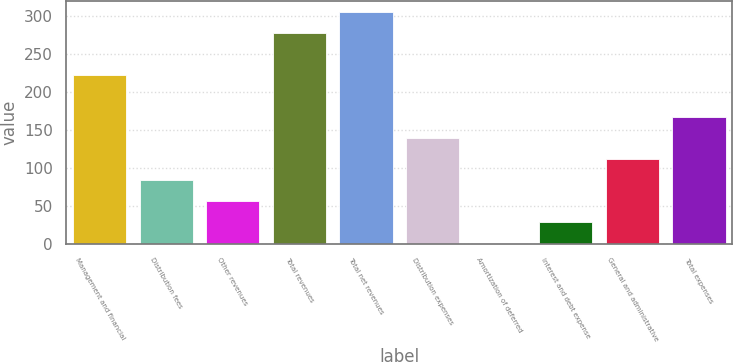<chart> <loc_0><loc_0><loc_500><loc_500><bar_chart><fcel>Management and financial<fcel>Distribution fees<fcel>Other revenues<fcel>Total revenues<fcel>Total net revenues<fcel>Distribution expenses<fcel>Amortization of deferred<fcel>Interest and debt expense<fcel>General and administrative<fcel>Total expenses<nl><fcel>223<fcel>84.1<fcel>56.4<fcel>278<fcel>305.7<fcel>139.5<fcel>1<fcel>28.7<fcel>111.8<fcel>167.2<nl></chart> 